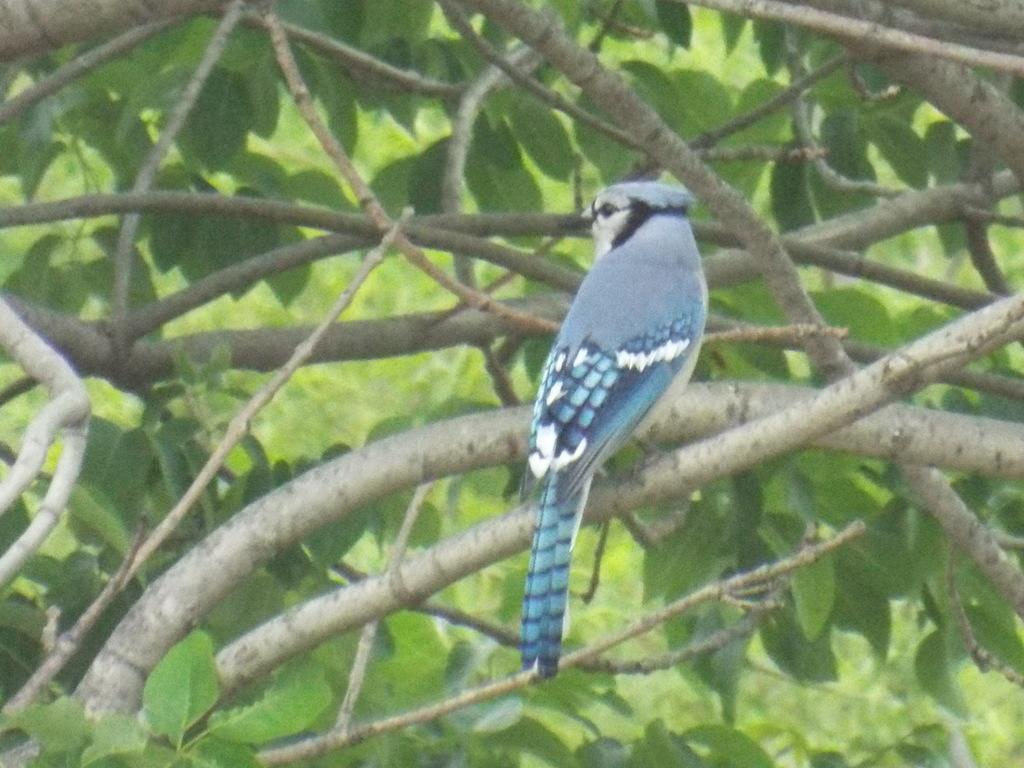Describe this image in one or two sentences. In this image I can see a bird on the branch. Back I can see few green leaves. Bird is in blue and white color. 